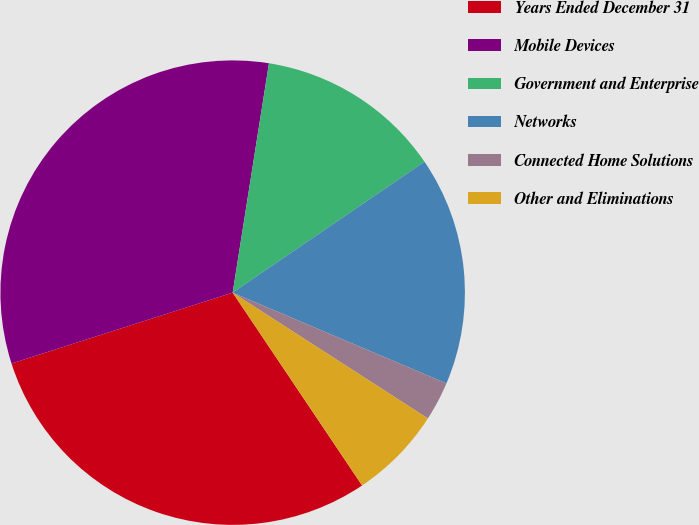<chart> <loc_0><loc_0><loc_500><loc_500><pie_chart><fcel>Years Ended December 31<fcel>Mobile Devices<fcel>Government and Enterprise<fcel>Networks<fcel>Connected Home Solutions<fcel>Other and Eliminations<nl><fcel>29.47%<fcel>32.43%<fcel>12.97%<fcel>15.92%<fcel>2.72%<fcel>6.48%<nl></chart> 